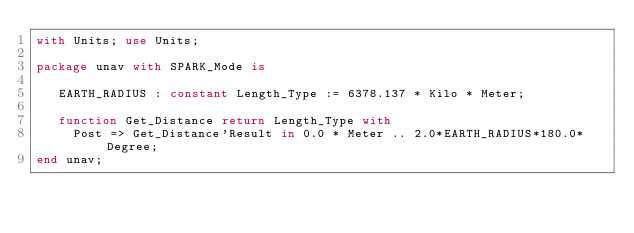<code> <loc_0><loc_0><loc_500><loc_500><_Ada_>with Units; use Units;

package unav with SPARK_Mode is

   EARTH_RADIUS : constant Length_Type := 6378.137 * Kilo * Meter;

   function Get_Distance return Length_Type with
     Post => Get_Distance'Result in 0.0 * Meter .. 2.0*EARTH_RADIUS*180.0*Degree;
end unav;
</code> 